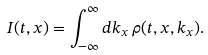<formula> <loc_0><loc_0><loc_500><loc_500>I ( t , x ) = \int _ { - \infty } ^ { \infty } d k _ { x } \, \rho ( t , x , k _ { x } ) .</formula> 